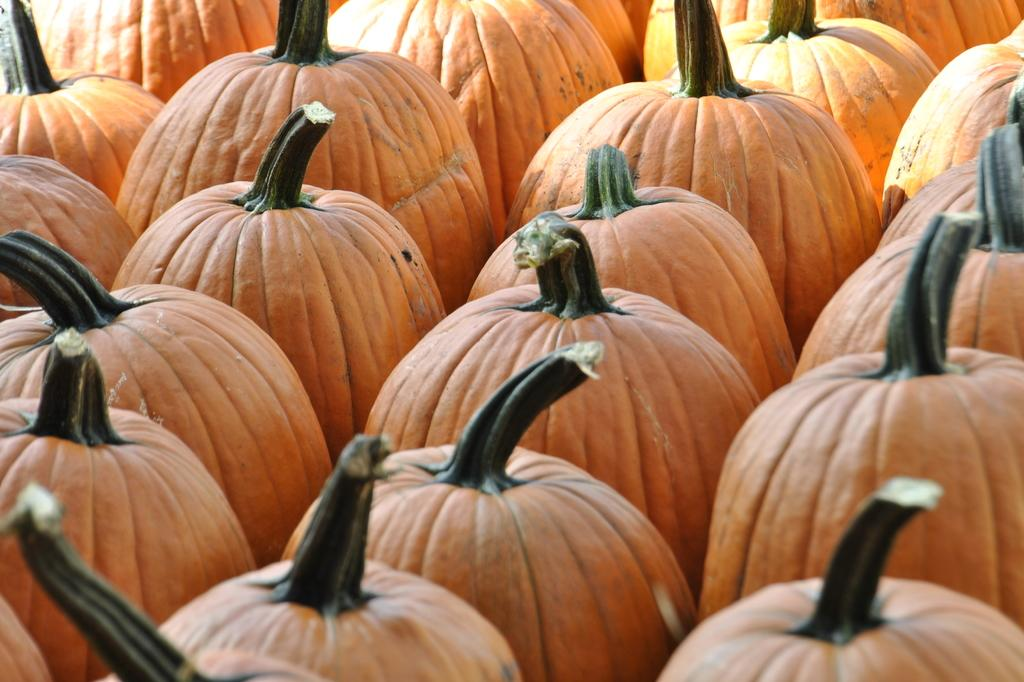What type of objects are present in the image? There are pumpkins in the image. What color are the pumpkins? The pumpkins are orange in color. Can you see a person wearing a feather in the image? There is no person or feather present in the image; it only features pumpkins. Is there any coal visible in the image? There is no coal present in the image; it only features pumpkins. 